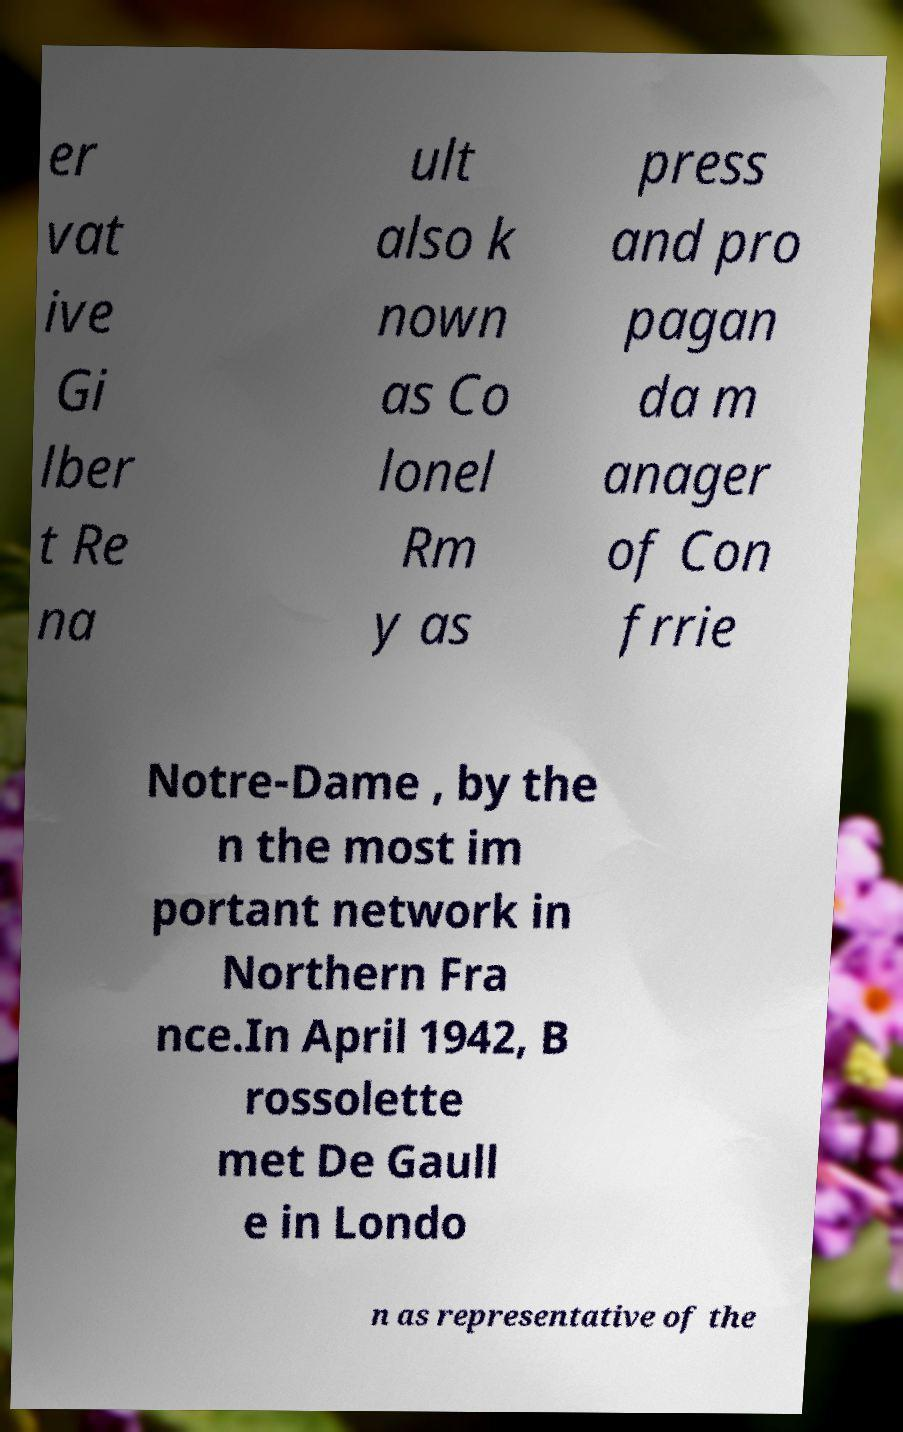Can you read and provide the text displayed in the image?This photo seems to have some interesting text. Can you extract and type it out for me? er vat ive Gi lber t Re na ult also k nown as Co lonel Rm y as press and pro pagan da m anager of Con frrie Notre-Dame , by the n the most im portant network in Northern Fra nce.In April 1942, B rossolette met De Gaull e in Londo n as representative of the 